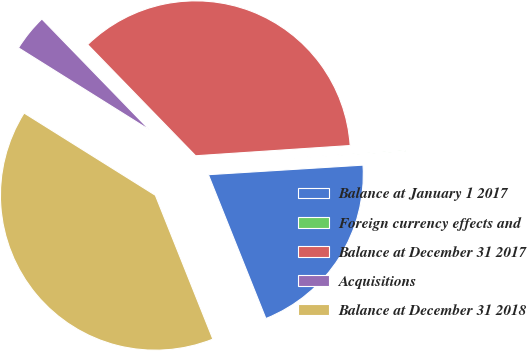<chart> <loc_0><loc_0><loc_500><loc_500><pie_chart><fcel>Balance at January 1 2017<fcel>Foreign currency effects and<fcel>Balance at December 31 2017<fcel>Acquisitions<fcel>Balance at December 31 2018<nl><fcel>19.93%<fcel>0.07%<fcel>36.21%<fcel>3.83%<fcel>39.96%<nl></chart> 